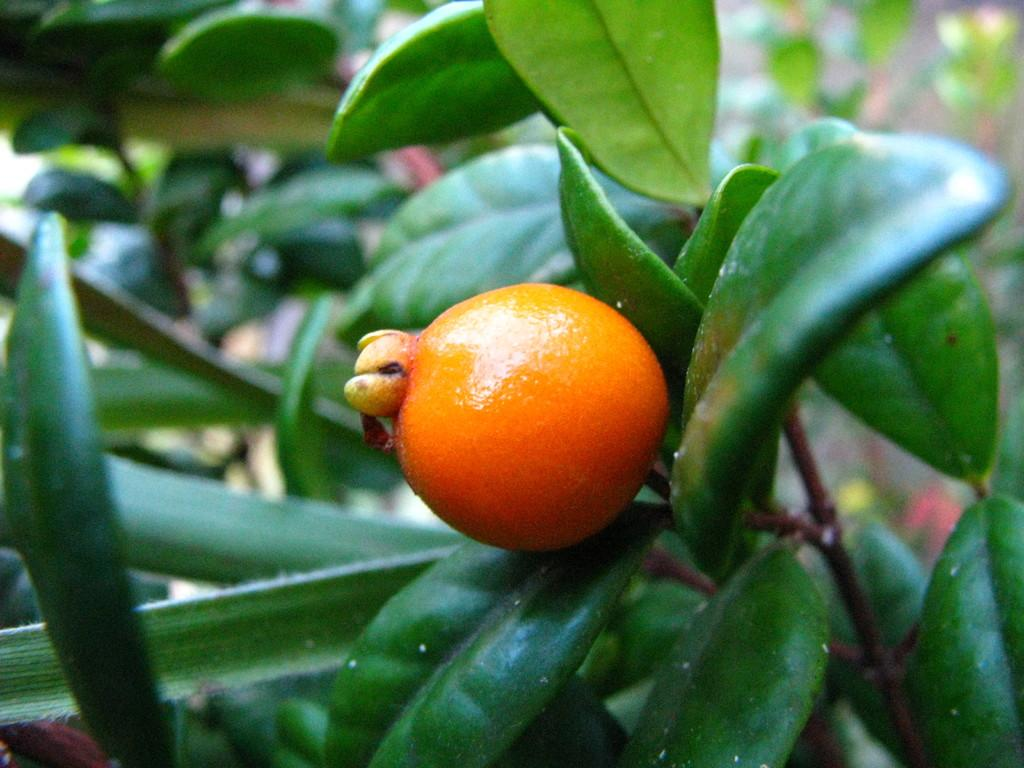What type of food is present in the image? There is a fruit in the image. What else can be seen in the image besides the fruit? There is a group of leaves in the image. How many cushions are present in the image? There are no cushions present in the image. What type of sugar is being used to sweeten the fruit in the image? There is no sugar present in the image, and the fruit is not being sweetened. 